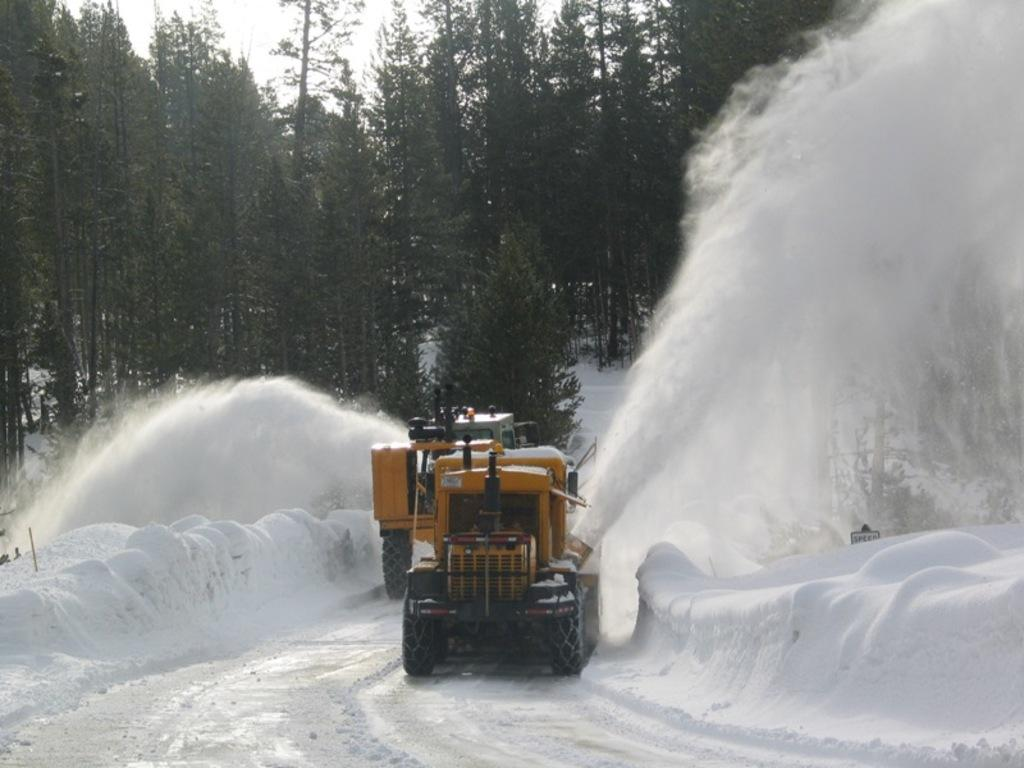What can be seen on the road in the image? There are two vehicles on the road in the image. What is the weather condition in the image? There is snow on both the left and right sides of the image, indicating a snowy condition. What type of vegetation is visible in the image? There are trees visible at the back of the image. What is visible at the top of the image? The sky is visible at the top of the image. What type of throat condition does the driver of the first vehicle have in the image? There is no information about the driver's throat condition in the image. How many sons does the driver of the second vehicle have in the image? There is no information about the driver's sons in the image. 